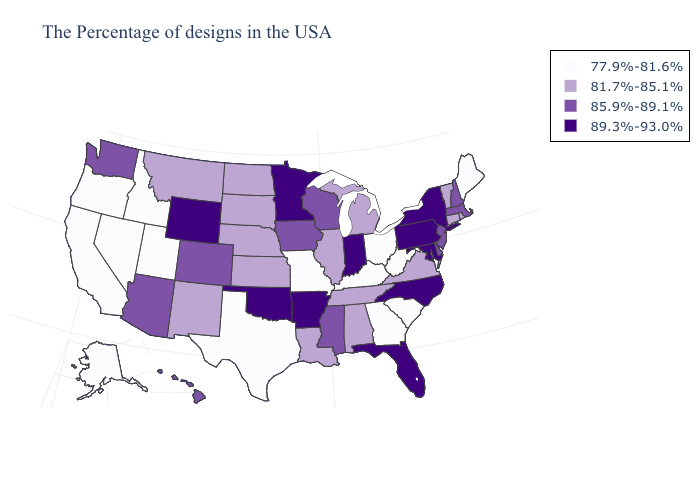What is the value of Georgia?
Quick response, please. 77.9%-81.6%. What is the value of Wisconsin?
Short answer required. 85.9%-89.1%. What is the highest value in states that border Tennessee?
Give a very brief answer. 89.3%-93.0%. What is the value of Kansas?
Answer briefly. 81.7%-85.1%. Does Hawaii have the highest value in the USA?
Answer briefly. No. What is the highest value in the USA?
Quick response, please. 89.3%-93.0%. What is the highest value in states that border Mississippi?
Give a very brief answer. 89.3%-93.0%. Which states hav the highest value in the Northeast?
Give a very brief answer. New York, Pennsylvania. What is the highest value in states that border Minnesota?
Quick response, please. 85.9%-89.1%. Name the states that have a value in the range 89.3%-93.0%?
Answer briefly. New York, Maryland, Pennsylvania, North Carolina, Florida, Indiana, Arkansas, Minnesota, Oklahoma, Wyoming. Is the legend a continuous bar?
Concise answer only. No. Which states have the lowest value in the USA?
Quick response, please. Maine, South Carolina, West Virginia, Ohio, Georgia, Kentucky, Missouri, Texas, Utah, Idaho, Nevada, California, Oregon, Alaska. Name the states that have a value in the range 89.3%-93.0%?
Be succinct. New York, Maryland, Pennsylvania, North Carolina, Florida, Indiana, Arkansas, Minnesota, Oklahoma, Wyoming. Among the states that border Arizona , which have the highest value?
Answer briefly. Colorado. What is the lowest value in the USA?
Concise answer only. 77.9%-81.6%. 